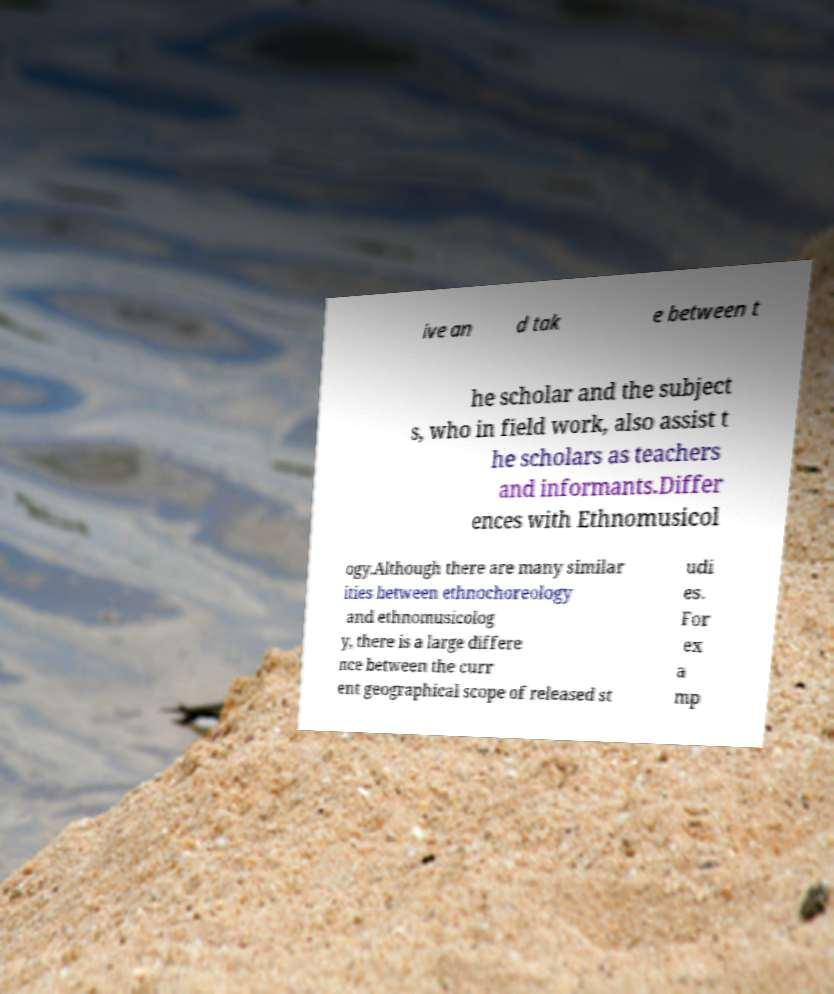Could you assist in decoding the text presented in this image and type it out clearly? ive an d tak e between t he scholar and the subject s, who in field work, also assist t he scholars as teachers and informants.Differ ences with Ethnomusicol ogy.Although there are many similar ities between ethnochoreology and ethnomusicolog y, there is a large differe nce between the curr ent geographical scope of released st udi es. For ex a mp 